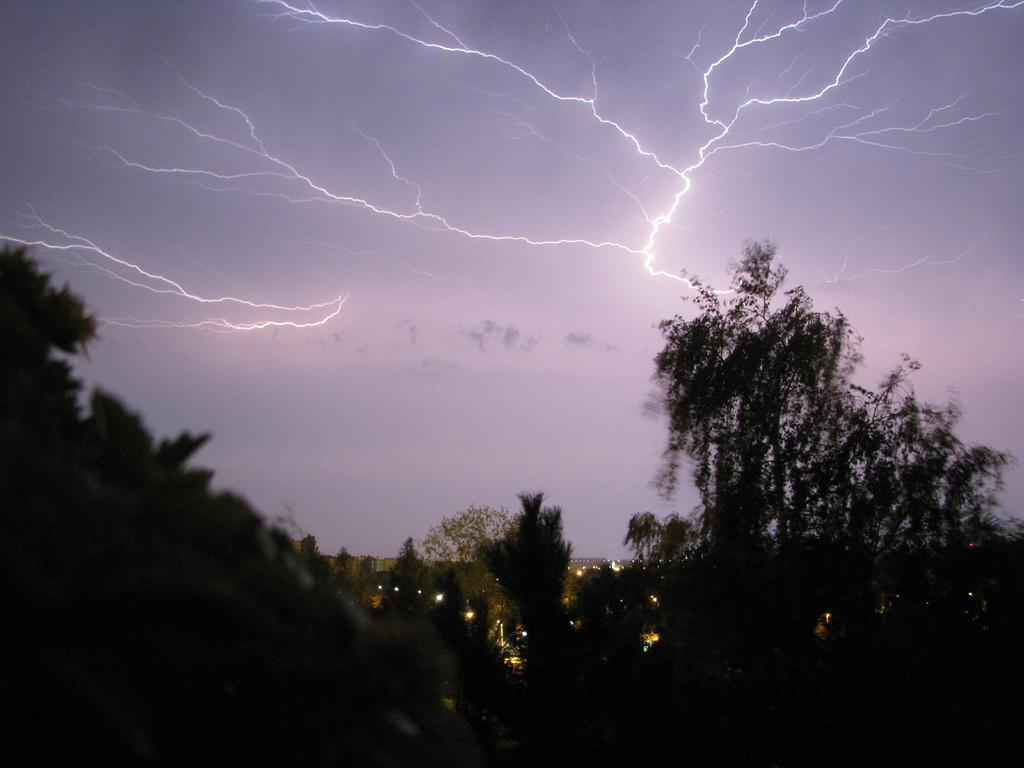What is the lighting condition in the image? The image was taken in the dark. What can be seen at the bottom of the image? There are trees and lights visible at the bottom of the image. What is happening in the sky at the top of the image? Thunder can be seen in the sky at the top of the image. Who is the father of the person holding the crate in the image? There is no person holding a crate in the image, and therefore no father can be identified. 